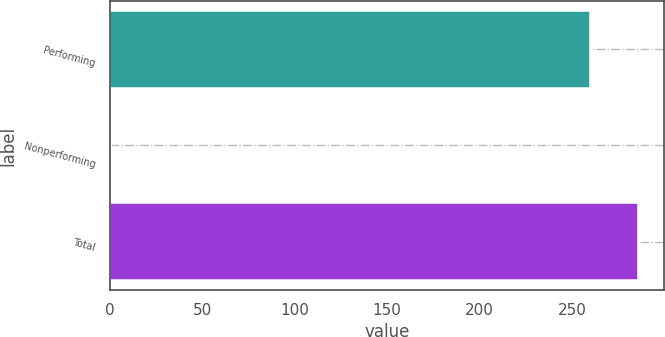<chart> <loc_0><loc_0><loc_500><loc_500><bar_chart><fcel>Performing<fcel>Nonperforming<fcel>Total<nl><fcel>259.4<fcel>0.9<fcel>285.34<nl></chart> 